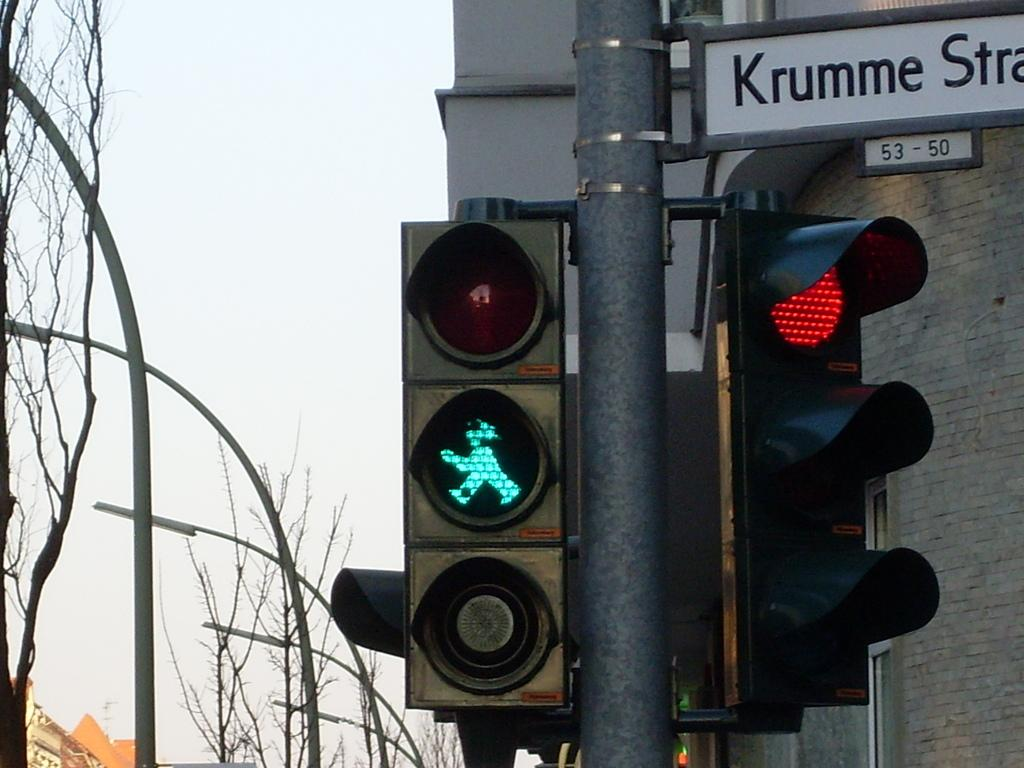<image>
Provide a brief description of the given image. The traffic light on Krumme Street is red and the pedestrian crossing light is a green person, informing pedestrians it is safe to walk. 